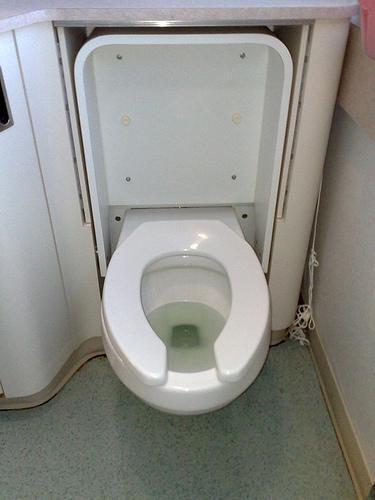How many toilets are pictured?
Give a very brief answer. 1. 